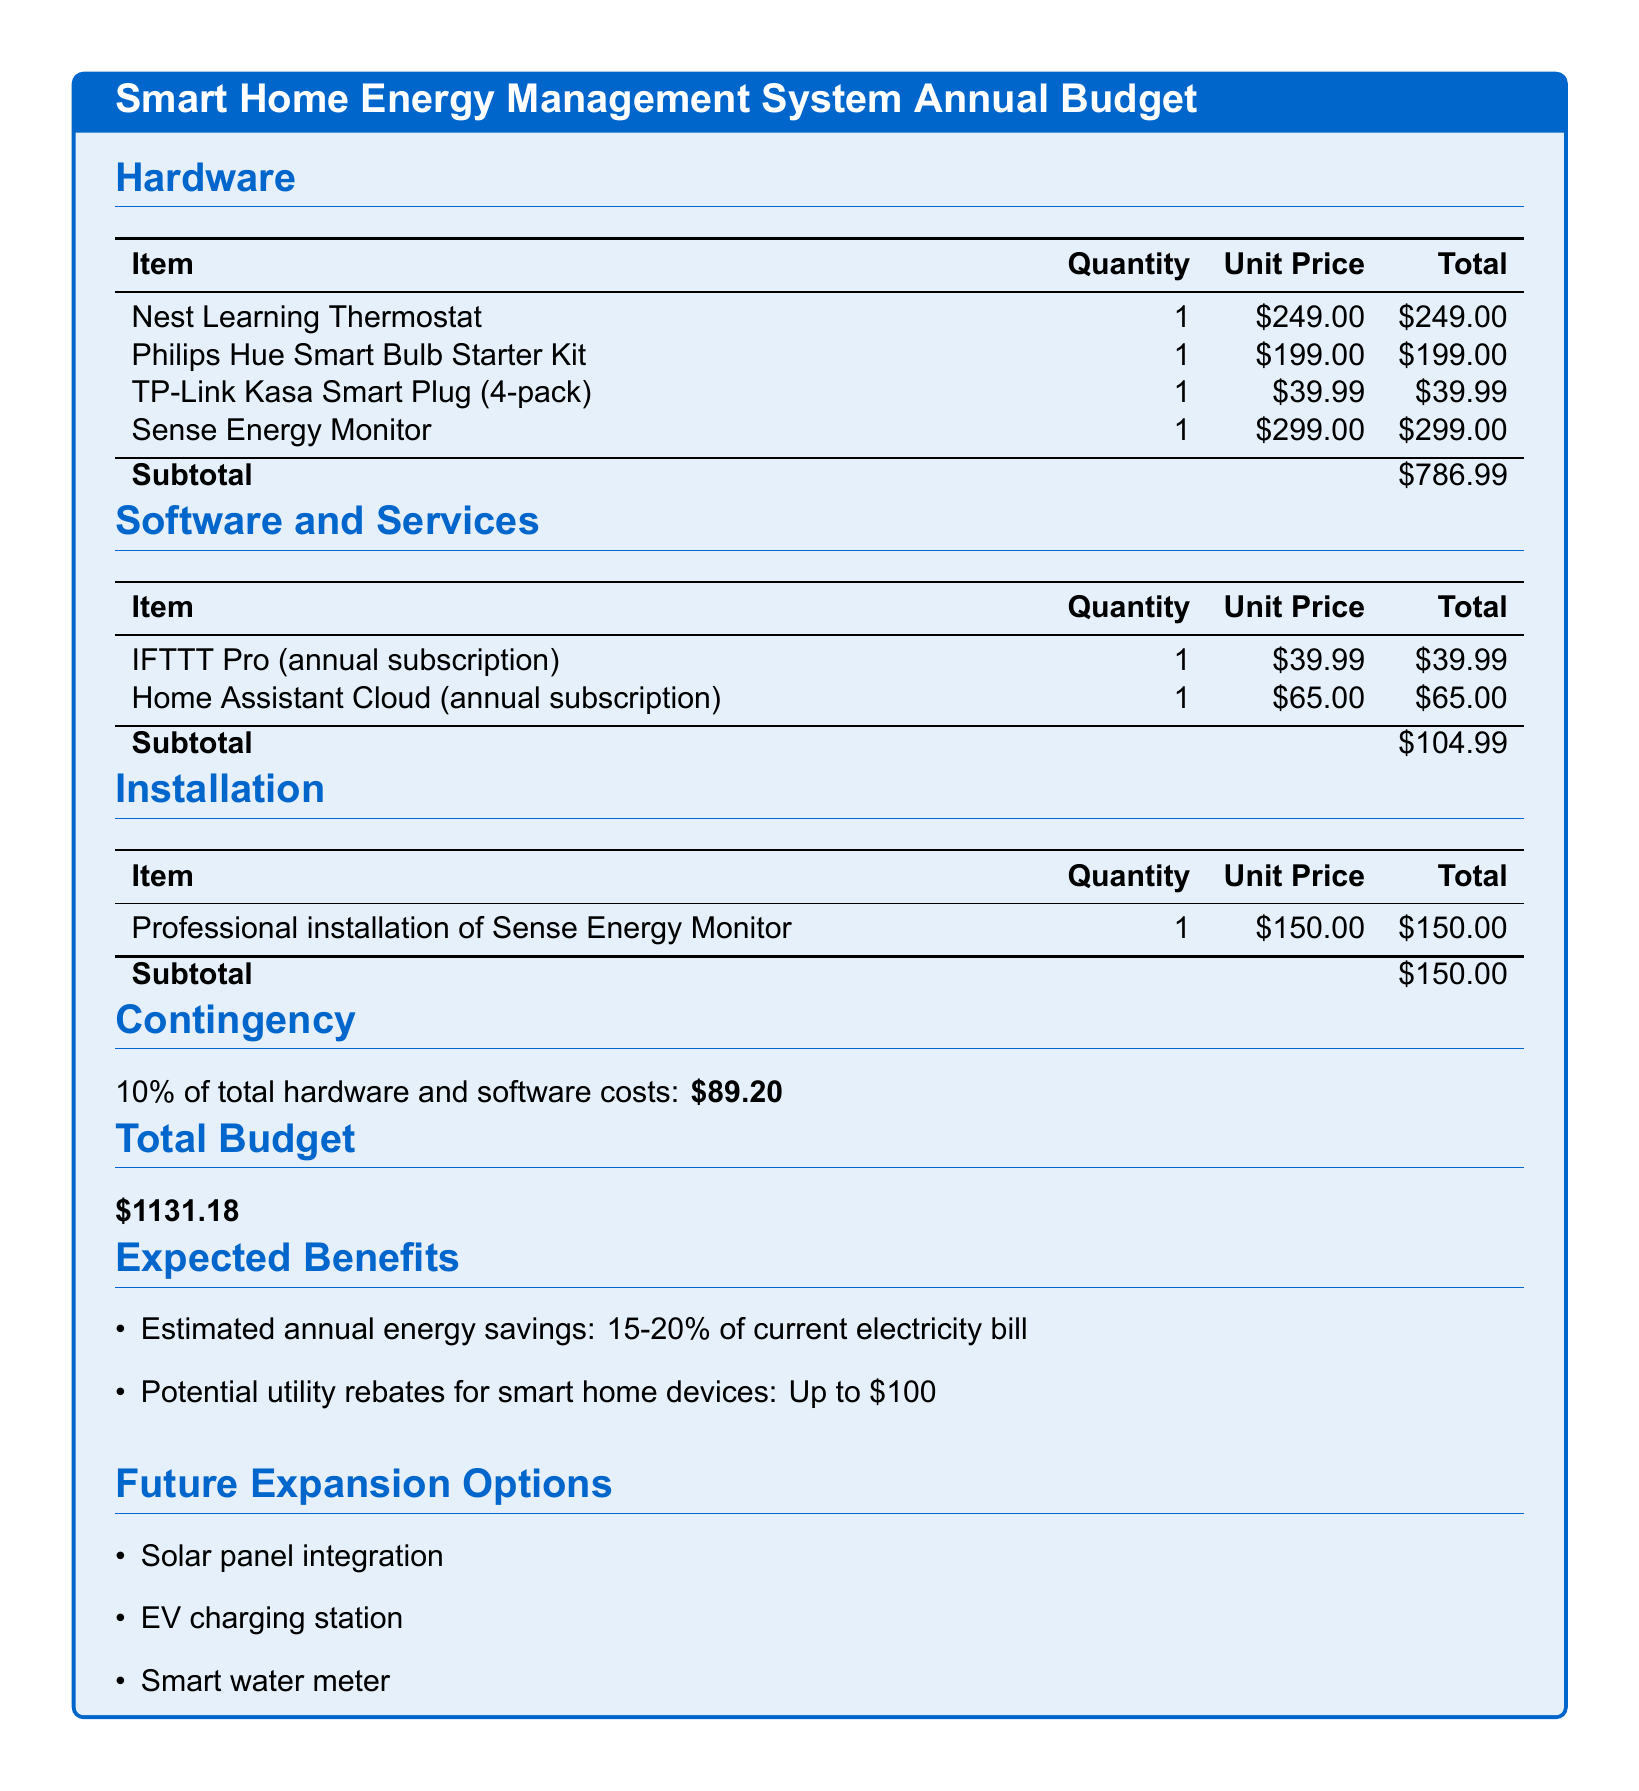What is the total budget? The total budget is the sum of hardware, software, installation, and contingency costs, which totals $1131.18.
Answer: $1131.18 What is the unit price of the Nest Learning Thermostat? The unit price of the Nest Learning Thermostat is listed in the Hardware section of the document.
Answer: $249.00 How much are the estimated annual energy savings? The estimated annual energy savings are mentioned in the Expected Benefits section, providing a range for savings.
Answer: 15-20% What is the quantity of TP-Link Kasa Smart Plugs? The quantity of TP-Link Kasa Smart Plugs is specified in the Hardware section of the document.
Answer: 1 What is the subtotal for software and services? The subtotal for software and services is calculated from the unit prices and quantities of items listed in that section.
Answer: $104.99 What is the contingency percentage? The contingency percentage is noted in the Contingency section of the document.
Answer: 10% How much does professional installation of the Sense Energy Monitor cost? The cost for professional installation is mentioned in the Installation section of the document.
Answer: $150.00 What are the potential utility rebates for smart home devices? The potential utility rebates are provided in the Expected Benefits section, indicating the total amount possible.
Answer: Up to $100 What is one of the future expansion options? Future expansion options are listed at the end of the document, giving examples of possible enhancements.
Answer: Solar panel integration 